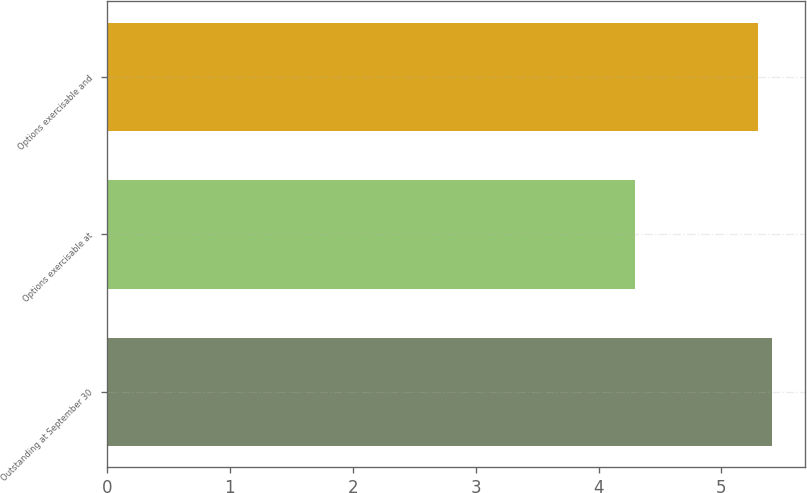Convert chart to OTSL. <chart><loc_0><loc_0><loc_500><loc_500><bar_chart><fcel>Outstanding at September 30<fcel>Options exercisable at<fcel>Options exercisable and<nl><fcel>5.41<fcel>4.3<fcel>5.3<nl></chart> 